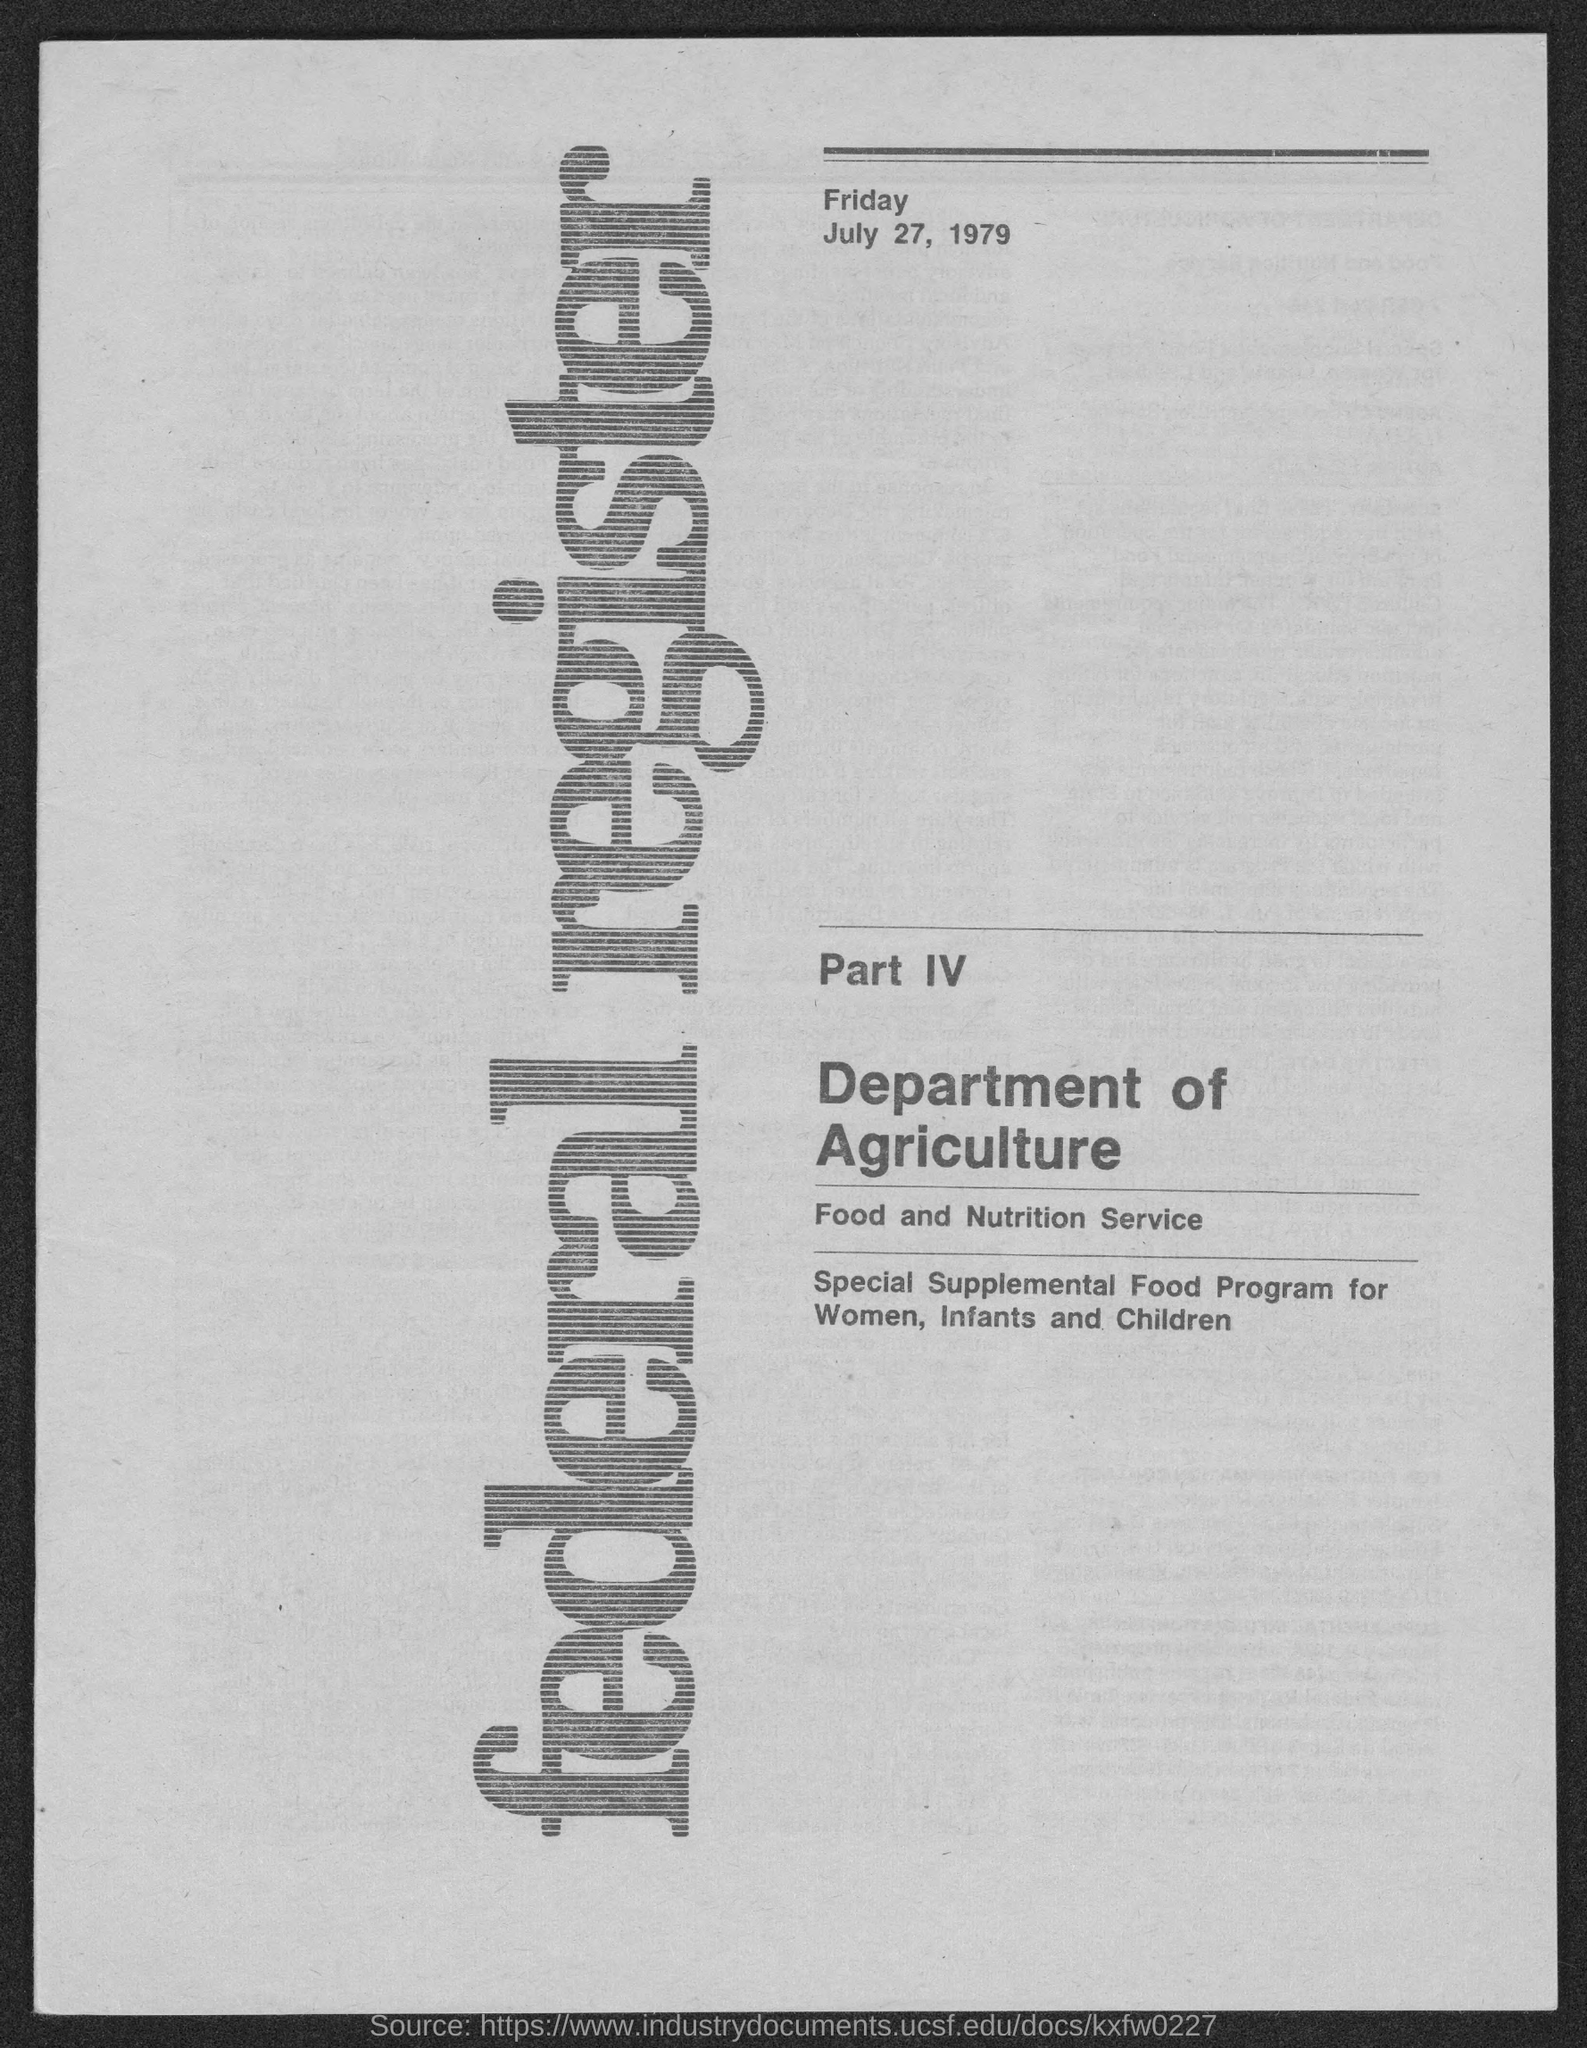What is the date mentioned in the given page?
Your response must be concise. July 27, 1979. What is the day mentioned in the given page ?
Give a very brief answer. Friday. What is the name of the department mentioned in the given form ?
Make the answer very short. Department of Agriculture. What is the name of the service mentioned in the given page ?
Offer a terse response. Food and nutrition service. What is the name of the register mentioned in the given page ?
Make the answer very short. Federal register. For whom the special supplemental food program was conducted ?
Offer a terse response. Women , infants and children. 